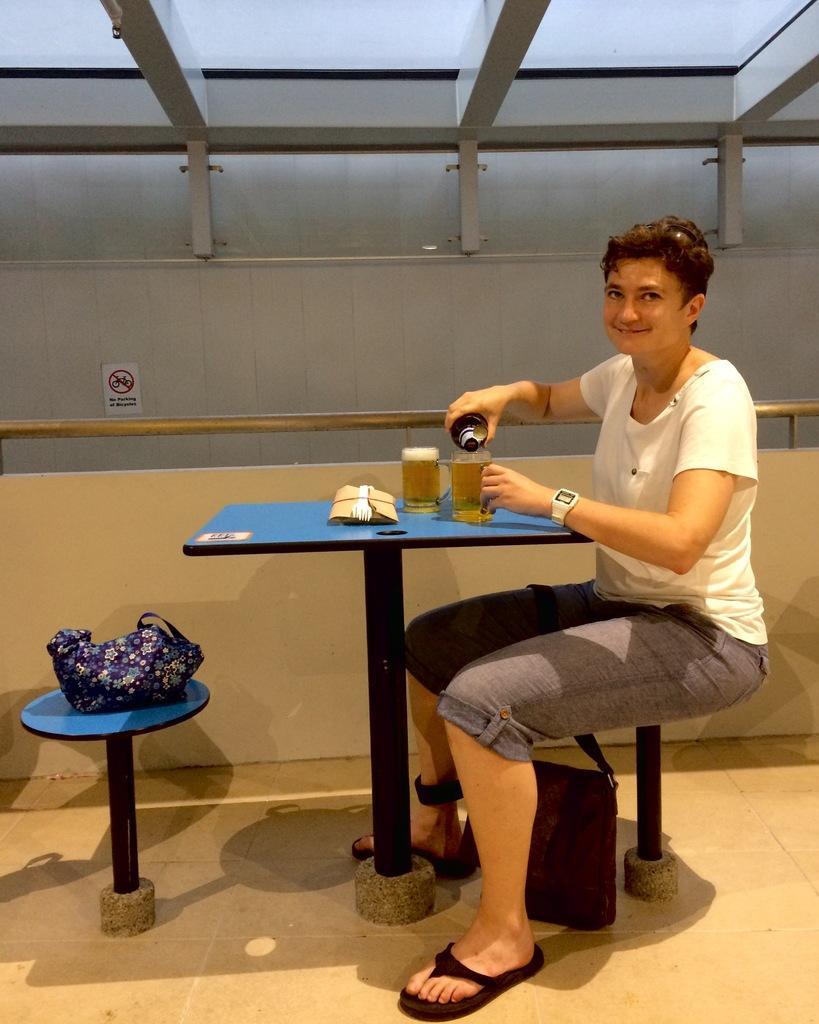In one or two sentences, can you explain what this image depicts? This image consists of a woman wearing white T-shirt is sitting and pouring beer in the glass. In front of her, there is a table. At the bottom, there is a floor. In the background, there is a wall along with the railing. At the top, there is a roof. 